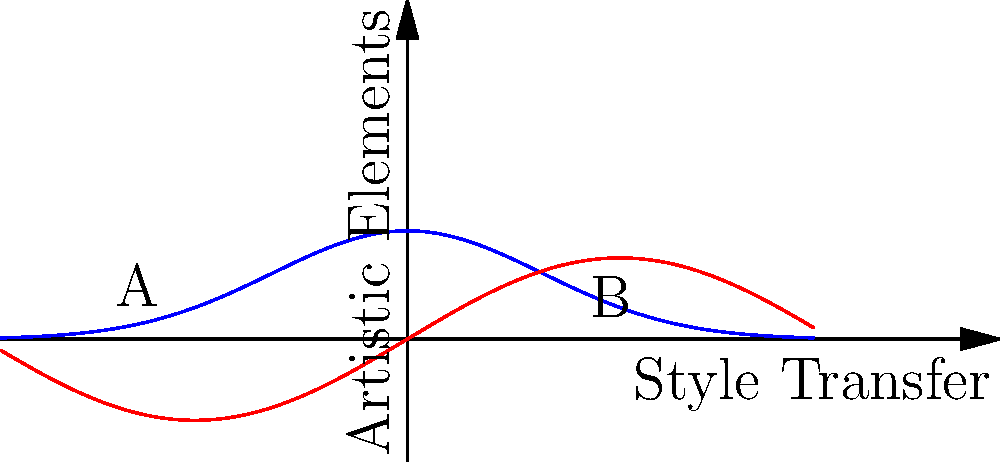As an illustrator exploring style transfer between different art mediums, you're working on transferring the style of an oil painting to a digital artwork. The graph shows two curves representing the artistic elements of an oil painting (blue) and a digital artwork (red) across a style transfer process. At which point in the style transfer process would you expect to see the most balanced blend of both mediums' characteristics? To determine the point of most balanced blend between the oil painting and digital artwork styles, we need to follow these steps:

1. Understand the graph:
   - The x-axis represents the style transfer process.
   - The y-axis represents the prominence of artistic elements.
   - The blue curve represents the oil painting style.
   - The red curve represents the digital artwork style.

2. Analyze the curves:
   - The oil painting curve (blue) is a Gaussian-like function, peaking near the center and tapering off at the edges.
   - The digital artwork curve (red) is a sine-like function, oscillating across the x-axis.

3. Find the intersection:
   - Look for where the two curves cross each other.
   - This intersection represents a point where both styles have equal prominence.

4. Evaluate the balance:
   - The most balanced blend would occur near this intersection point.
   - It's slightly to the right of the center of the graph, where both curves have moderate, similar values.

5. Consider the context:
   - As an illustrator, you're looking for a point where characteristics of both mediums are present but neither dominates.
   - This point should be where the oil painting's texture and depth blend well with the digital art's precision and versatility.

The point of intersection, slightly right of center, represents this optimal balance. Here, the rich textures and depth of oil painting would meld with the crisp lines and digital effects of the computer-generated art, creating a unique hybrid style that showcases the strengths of both mediums.
Answer: At the intersection point of the two curves, slightly right of center. 